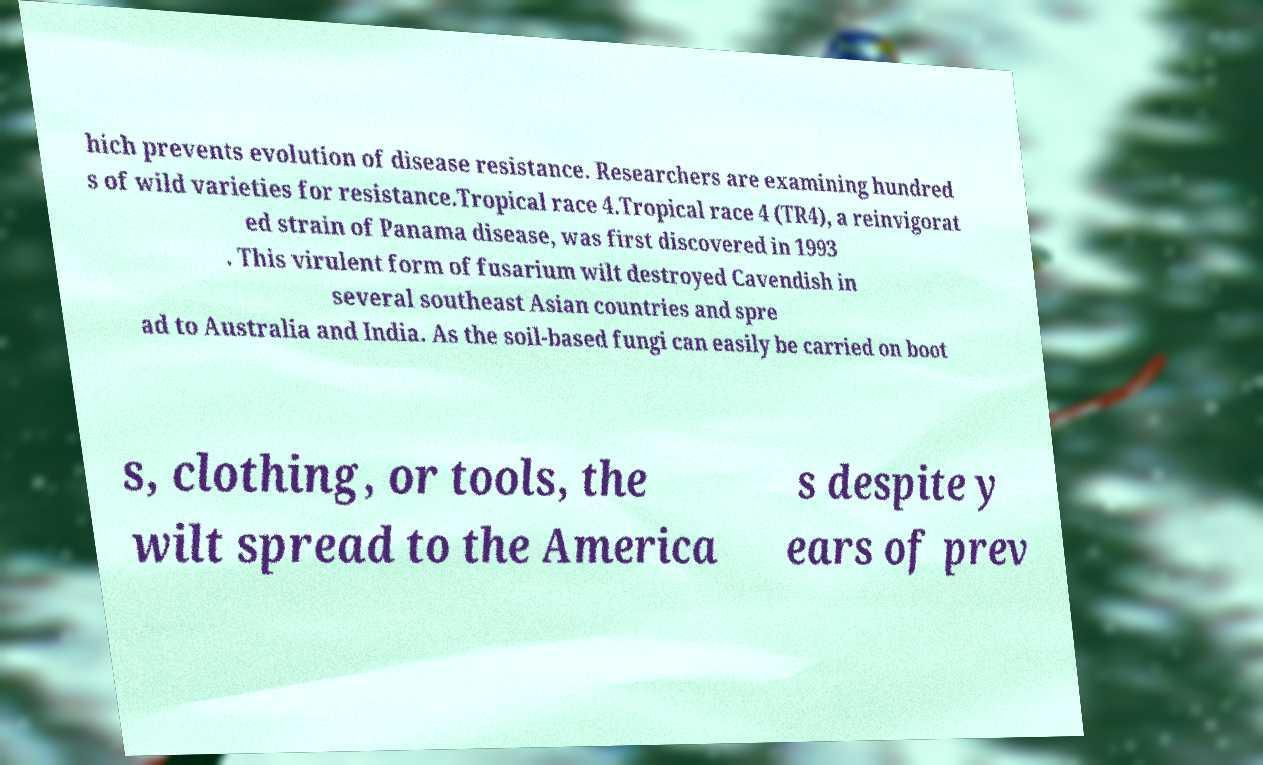For documentation purposes, I need the text within this image transcribed. Could you provide that? hich prevents evolution of disease resistance. Researchers are examining hundred s of wild varieties for resistance.Tropical race 4.Tropical race 4 (TR4), a reinvigorat ed strain of Panama disease, was first discovered in 1993 . This virulent form of fusarium wilt destroyed Cavendish in several southeast Asian countries and spre ad to Australia and India. As the soil-based fungi can easily be carried on boot s, clothing, or tools, the wilt spread to the America s despite y ears of prev 